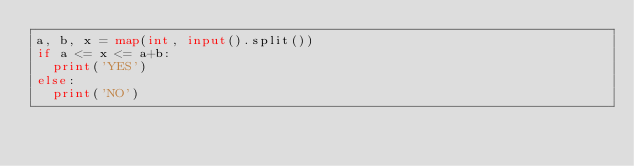Convert code to text. <code><loc_0><loc_0><loc_500><loc_500><_Python_>a, b, x = map(int, input().split())
if a <= x <= a+b:
  print('YES')
else:
  print('NO')</code> 